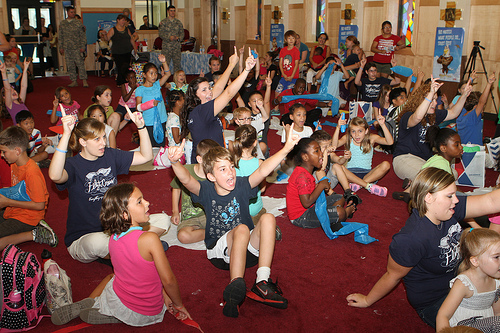<image>
Is the girl on the woman? No. The girl is not positioned on the woman. They may be near each other, but the girl is not supported by or resting on top of the woman. 